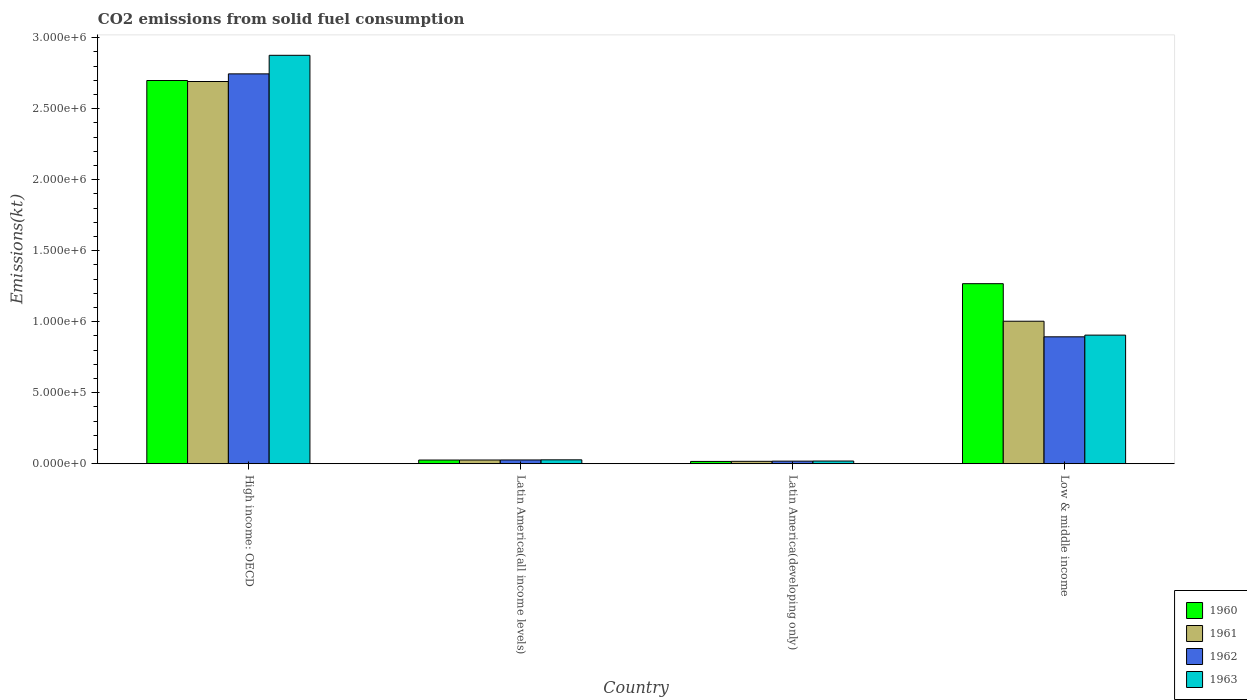How many groups of bars are there?
Keep it short and to the point. 4. Are the number of bars per tick equal to the number of legend labels?
Your answer should be compact. Yes. Are the number of bars on each tick of the X-axis equal?
Make the answer very short. Yes. What is the label of the 4th group of bars from the left?
Offer a terse response. Low & middle income. What is the amount of CO2 emitted in 1961 in Latin America(all income levels)?
Give a very brief answer. 2.63e+04. Across all countries, what is the maximum amount of CO2 emitted in 1962?
Your answer should be very brief. 2.75e+06. Across all countries, what is the minimum amount of CO2 emitted in 1962?
Your response must be concise. 1.83e+04. In which country was the amount of CO2 emitted in 1963 maximum?
Give a very brief answer. High income: OECD. In which country was the amount of CO2 emitted in 1960 minimum?
Give a very brief answer. Latin America(developing only). What is the total amount of CO2 emitted in 1962 in the graph?
Your answer should be very brief. 3.68e+06. What is the difference between the amount of CO2 emitted in 1963 in Latin America(all income levels) and that in Low & middle income?
Offer a terse response. -8.78e+05. What is the difference between the amount of CO2 emitted in 1961 in Latin America(all income levels) and the amount of CO2 emitted in 1962 in Low & middle income?
Give a very brief answer. -8.67e+05. What is the average amount of CO2 emitted in 1960 per country?
Provide a succinct answer. 1.00e+06. What is the difference between the amount of CO2 emitted of/in 1960 and amount of CO2 emitted of/in 1961 in Low & middle income?
Provide a succinct answer. 2.64e+05. What is the ratio of the amount of CO2 emitted in 1960 in Latin America(developing only) to that in Low & middle income?
Offer a very short reply. 0.01. Is the amount of CO2 emitted in 1963 in Latin America(developing only) less than that in Low & middle income?
Offer a very short reply. Yes. Is the difference between the amount of CO2 emitted in 1960 in High income: OECD and Latin America(all income levels) greater than the difference between the amount of CO2 emitted in 1961 in High income: OECD and Latin America(all income levels)?
Give a very brief answer. Yes. What is the difference between the highest and the second highest amount of CO2 emitted in 1962?
Offer a very short reply. 8.67e+05. What is the difference between the highest and the lowest amount of CO2 emitted in 1961?
Offer a very short reply. 2.67e+06. Is it the case that in every country, the sum of the amount of CO2 emitted in 1962 and amount of CO2 emitted in 1963 is greater than the sum of amount of CO2 emitted in 1961 and amount of CO2 emitted in 1960?
Provide a succinct answer. No. What does the 2nd bar from the left in Low & middle income represents?
Keep it short and to the point. 1961. Is it the case that in every country, the sum of the amount of CO2 emitted in 1962 and amount of CO2 emitted in 1961 is greater than the amount of CO2 emitted in 1960?
Offer a terse response. Yes. Are all the bars in the graph horizontal?
Provide a succinct answer. No. Are the values on the major ticks of Y-axis written in scientific E-notation?
Keep it short and to the point. Yes. Does the graph contain grids?
Make the answer very short. No. How many legend labels are there?
Keep it short and to the point. 4. What is the title of the graph?
Ensure brevity in your answer.  CO2 emissions from solid fuel consumption. Does "1995" appear as one of the legend labels in the graph?
Provide a succinct answer. No. What is the label or title of the Y-axis?
Provide a succinct answer. Emissions(kt). What is the Emissions(kt) in 1960 in High income: OECD?
Your answer should be very brief. 2.70e+06. What is the Emissions(kt) in 1961 in High income: OECD?
Provide a short and direct response. 2.69e+06. What is the Emissions(kt) of 1962 in High income: OECD?
Provide a succinct answer. 2.75e+06. What is the Emissions(kt) in 1963 in High income: OECD?
Your answer should be compact. 2.88e+06. What is the Emissions(kt) in 1960 in Latin America(all income levels)?
Your response must be concise. 2.60e+04. What is the Emissions(kt) of 1961 in Latin America(all income levels)?
Provide a short and direct response. 2.63e+04. What is the Emissions(kt) in 1962 in Latin America(all income levels)?
Your answer should be compact. 2.67e+04. What is the Emissions(kt) in 1963 in Latin America(all income levels)?
Ensure brevity in your answer.  2.75e+04. What is the Emissions(kt) in 1960 in Latin America(developing only)?
Ensure brevity in your answer.  1.62e+04. What is the Emissions(kt) of 1961 in Latin America(developing only)?
Make the answer very short. 1.70e+04. What is the Emissions(kt) of 1962 in Latin America(developing only)?
Provide a succinct answer. 1.83e+04. What is the Emissions(kt) of 1963 in Latin America(developing only)?
Keep it short and to the point. 1.90e+04. What is the Emissions(kt) in 1960 in Low & middle income?
Your answer should be very brief. 1.27e+06. What is the Emissions(kt) in 1961 in Low & middle income?
Offer a terse response. 1.00e+06. What is the Emissions(kt) of 1962 in Low & middle income?
Your answer should be compact. 8.94e+05. What is the Emissions(kt) of 1963 in Low & middle income?
Your response must be concise. 9.06e+05. Across all countries, what is the maximum Emissions(kt) of 1960?
Provide a short and direct response. 2.70e+06. Across all countries, what is the maximum Emissions(kt) of 1961?
Ensure brevity in your answer.  2.69e+06. Across all countries, what is the maximum Emissions(kt) of 1962?
Provide a short and direct response. 2.75e+06. Across all countries, what is the maximum Emissions(kt) of 1963?
Your answer should be compact. 2.88e+06. Across all countries, what is the minimum Emissions(kt) in 1960?
Make the answer very short. 1.62e+04. Across all countries, what is the minimum Emissions(kt) in 1961?
Provide a short and direct response. 1.70e+04. Across all countries, what is the minimum Emissions(kt) in 1962?
Your response must be concise. 1.83e+04. Across all countries, what is the minimum Emissions(kt) of 1963?
Provide a succinct answer. 1.90e+04. What is the total Emissions(kt) of 1960 in the graph?
Keep it short and to the point. 4.01e+06. What is the total Emissions(kt) in 1961 in the graph?
Keep it short and to the point. 3.74e+06. What is the total Emissions(kt) in 1962 in the graph?
Provide a succinct answer. 3.68e+06. What is the total Emissions(kt) in 1963 in the graph?
Offer a very short reply. 3.83e+06. What is the difference between the Emissions(kt) in 1960 in High income: OECD and that in Latin America(all income levels)?
Provide a short and direct response. 2.67e+06. What is the difference between the Emissions(kt) in 1961 in High income: OECD and that in Latin America(all income levels)?
Offer a very short reply. 2.67e+06. What is the difference between the Emissions(kt) of 1962 in High income: OECD and that in Latin America(all income levels)?
Offer a terse response. 2.72e+06. What is the difference between the Emissions(kt) of 1963 in High income: OECD and that in Latin America(all income levels)?
Your answer should be very brief. 2.85e+06. What is the difference between the Emissions(kt) in 1960 in High income: OECD and that in Latin America(developing only)?
Make the answer very short. 2.68e+06. What is the difference between the Emissions(kt) of 1961 in High income: OECD and that in Latin America(developing only)?
Give a very brief answer. 2.67e+06. What is the difference between the Emissions(kt) of 1962 in High income: OECD and that in Latin America(developing only)?
Ensure brevity in your answer.  2.73e+06. What is the difference between the Emissions(kt) in 1963 in High income: OECD and that in Latin America(developing only)?
Provide a succinct answer. 2.86e+06. What is the difference between the Emissions(kt) of 1960 in High income: OECD and that in Low & middle income?
Make the answer very short. 1.43e+06. What is the difference between the Emissions(kt) of 1961 in High income: OECD and that in Low & middle income?
Your answer should be compact. 1.69e+06. What is the difference between the Emissions(kt) of 1962 in High income: OECD and that in Low & middle income?
Your answer should be compact. 1.85e+06. What is the difference between the Emissions(kt) in 1963 in High income: OECD and that in Low & middle income?
Your response must be concise. 1.97e+06. What is the difference between the Emissions(kt) of 1960 in Latin America(all income levels) and that in Latin America(developing only)?
Ensure brevity in your answer.  9759.8. What is the difference between the Emissions(kt) in 1961 in Latin America(all income levels) and that in Latin America(developing only)?
Offer a very short reply. 9282.45. What is the difference between the Emissions(kt) in 1962 in Latin America(all income levels) and that in Latin America(developing only)?
Your answer should be compact. 8301.83. What is the difference between the Emissions(kt) of 1963 in Latin America(all income levels) and that in Latin America(developing only)?
Make the answer very short. 8542.91. What is the difference between the Emissions(kt) of 1960 in Latin America(all income levels) and that in Low & middle income?
Provide a short and direct response. -1.24e+06. What is the difference between the Emissions(kt) in 1961 in Latin America(all income levels) and that in Low & middle income?
Keep it short and to the point. -9.77e+05. What is the difference between the Emissions(kt) of 1962 in Latin America(all income levels) and that in Low & middle income?
Ensure brevity in your answer.  -8.67e+05. What is the difference between the Emissions(kt) of 1963 in Latin America(all income levels) and that in Low & middle income?
Provide a succinct answer. -8.78e+05. What is the difference between the Emissions(kt) of 1960 in Latin America(developing only) and that in Low & middle income?
Make the answer very short. -1.25e+06. What is the difference between the Emissions(kt) in 1961 in Latin America(developing only) and that in Low & middle income?
Offer a very short reply. -9.86e+05. What is the difference between the Emissions(kt) in 1962 in Latin America(developing only) and that in Low & middle income?
Provide a short and direct response. -8.75e+05. What is the difference between the Emissions(kt) of 1963 in Latin America(developing only) and that in Low & middle income?
Keep it short and to the point. -8.87e+05. What is the difference between the Emissions(kt) in 1960 in High income: OECD and the Emissions(kt) in 1961 in Latin America(all income levels)?
Ensure brevity in your answer.  2.67e+06. What is the difference between the Emissions(kt) of 1960 in High income: OECD and the Emissions(kt) of 1962 in Latin America(all income levels)?
Keep it short and to the point. 2.67e+06. What is the difference between the Emissions(kt) of 1960 in High income: OECD and the Emissions(kt) of 1963 in Latin America(all income levels)?
Provide a succinct answer. 2.67e+06. What is the difference between the Emissions(kt) in 1961 in High income: OECD and the Emissions(kt) in 1962 in Latin America(all income levels)?
Your answer should be very brief. 2.66e+06. What is the difference between the Emissions(kt) in 1961 in High income: OECD and the Emissions(kt) in 1963 in Latin America(all income levels)?
Offer a very short reply. 2.66e+06. What is the difference between the Emissions(kt) of 1962 in High income: OECD and the Emissions(kt) of 1963 in Latin America(all income levels)?
Give a very brief answer. 2.72e+06. What is the difference between the Emissions(kt) of 1960 in High income: OECD and the Emissions(kt) of 1961 in Latin America(developing only)?
Give a very brief answer. 2.68e+06. What is the difference between the Emissions(kt) in 1960 in High income: OECD and the Emissions(kt) in 1962 in Latin America(developing only)?
Ensure brevity in your answer.  2.68e+06. What is the difference between the Emissions(kt) in 1960 in High income: OECD and the Emissions(kt) in 1963 in Latin America(developing only)?
Offer a terse response. 2.68e+06. What is the difference between the Emissions(kt) in 1961 in High income: OECD and the Emissions(kt) in 1962 in Latin America(developing only)?
Offer a terse response. 2.67e+06. What is the difference between the Emissions(kt) of 1961 in High income: OECD and the Emissions(kt) of 1963 in Latin America(developing only)?
Give a very brief answer. 2.67e+06. What is the difference between the Emissions(kt) in 1962 in High income: OECD and the Emissions(kt) in 1963 in Latin America(developing only)?
Offer a very short reply. 2.73e+06. What is the difference between the Emissions(kt) of 1960 in High income: OECD and the Emissions(kt) of 1961 in Low & middle income?
Keep it short and to the point. 1.69e+06. What is the difference between the Emissions(kt) of 1960 in High income: OECD and the Emissions(kt) of 1962 in Low & middle income?
Ensure brevity in your answer.  1.80e+06. What is the difference between the Emissions(kt) in 1960 in High income: OECD and the Emissions(kt) in 1963 in Low & middle income?
Your answer should be very brief. 1.79e+06. What is the difference between the Emissions(kt) in 1961 in High income: OECD and the Emissions(kt) in 1962 in Low & middle income?
Your response must be concise. 1.80e+06. What is the difference between the Emissions(kt) of 1961 in High income: OECD and the Emissions(kt) of 1963 in Low & middle income?
Offer a very short reply. 1.79e+06. What is the difference between the Emissions(kt) in 1962 in High income: OECD and the Emissions(kt) in 1963 in Low & middle income?
Ensure brevity in your answer.  1.84e+06. What is the difference between the Emissions(kt) of 1960 in Latin America(all income levels) and the Emissions(kt) of 1961 in Latin America(developing only)?
Your answer should be compact. 9031.46. What is the difference between the Emissions(kt) of 1960 in Latin America(all income levels) and the Emissions(kt) of 1962 in Latin America(developing only)?
Provide a short and direct response. 7658.68. What is the difference between the Emissions(kt) of 1960 in Latin America(all income levels) and the Emissions(kt) of 1963 in Latin America(developing only)?
Ensure brevity in your answer.  7040.93. What is the difference between the Emissions(kt) in 1961 in Latin America(all income levels) and the Emissions(kt) in 1962 in Latin America(developing only)?
Make the answer very short. 7909.66. What is the difference between the Emissions(kt) of 1961 in Latin America(all income levels) and the Emissions(kt) of 1963 in Latin America(developing only)?
Provide a succinct answer. 7291.91. What is the difference between the Emissions(kt) of 1962 in Latin America(all income levels) and the Emissions(kt) of 1963 in Latin America(developing only)?
Your answer should be very brief. 7684.07. What is the difference between the Emissions(kt) in 1960 in Latin America(all income levels) and the Emissions(kt) in 1961 in Low & middle income?
Provide a succinct answer. -9.77e+05. What is the difference between the Emissions(kt) in 1960 in Latin America(all income levels) and the Emissions(kt) in 1962 in Low & middle income?
Keep it short and to the point. -8.68e+05. What is the difference between the Emissions(kt) in 1960 in Latin America(all income levels) and the Emissions(kt) in 1963 in Low & middle income?
Your answer should be very brief. -8.80e+05. What is the difference between the Emissions(kt) in 1961 in Latin America(all income levels) and the Emissions(kt) in 1962 in Low & middle income?
Your response must be concise. -8.67e+05. What is the difference between the Emissions(kt) of 1961 in Latin America(all income levels) and the Emissions(kt) of 1963 in Low & middle income?
Offer a very short reply. -8.79e+05. What is the difference between the Emissions(kt) in 1962 in Latin America(all income levels) and the Emissions(kt) in 1963 in Low & middle income?
Your response must be concise. -8.79e+05. What is the difference between the Emissions(kt) of 1960 in Latin America(developing only) and the Emissions(kt) of 1961 in Low & middle income?
Provide a succinct answer. -9.87e+05. What is the difference between the Emissions(kt) in 1960 in Latin America(developing only) and the Emissions(kt) in 1962 in Low & middle income?
Offer a terse response. -8.77e+05. What is the difference between the Emissions(kt) of 1960 in Latin America(developing only) and the Emissions(kt) of 1963 in Low & middle income?
Your response must be concise. -8.89e+05. What is the difference between the Emissions(kt) in 1961 in Latin America(developing only) and the Emissions(kt) in 1962 in Low & middle income?
Your answer should be compact. -8.77e+05. What is the difference between the Emissions(kt) of 1961 in Latin America(developing only) and the Emissions(kt) of 1963 in Low & middle income?
Provide a succinct answer. -8.89e+05. What is the difference between the Emissions(kt) of 1962 in Latin America(developing only) and the Emissions(kt) of 1963 in Low & middle income?
Your response must be concise. -8.87e+05. What is the average Emissions(kt) in 1960 per country?
Ensure brevity in your answer.  1.00e+06. What is the average Emissions(kt) of 1961 per country?
Offer a very short reply. 9.34e+05. What is the average Emissions(kt) of 1962 per country?
Provide a succinct answer. 9.21e+05. What is the average Emissions(kt) of 1963 per country?
Offer a very short reply. 9.57e+05. What is the difference between the Emissions(kt) of 1960 and Emissions(kt) of 1961 in High income: OECD?
Your answer should be compact. 7090.26. What is the difference between the Emissions(kt) in 1960 and Emissions(kt) in 1962 in High income: OECD?
Keep it short and to the point. -4.67e+04. What is the difference between the Emissions(kt) of 1960 and Emissions(kt) of 1963 in High income: OECD?
Offer a very short reply. -1.77e+05. What is the difference between the Emissions(kt) of 1961 and Emissions(kt) of 1962 in High income: OECD?
Offer a very short reply. -5.38e+04. What is the difference between the Emissions(kt) of 1961 and Emissions(kt) of 1963 in High income: OECD?
Offer a very short reply. -1.85e+05. What is the difference between the Emissions(kt) in 1962 and Emissions(kt) in 1963 in High income: OECD?
Offer a very short reply. -1.31e+05. What is the difference between the Emissions(kt) of 1960 and Emissions(kt) of 1961 in Latin America(all income levels)?
Provide a succinct answer. -250.98. What is the difference between the Emissions(kt) of 1960 and Emissions(kt) of 1962 in Latin America(all income levels)?
Give a very brief answer. -643.15. What is the difference between the Emissions(kt) in 1960 and Emissions(kt) in 1963 in Latin America(all income levels)?
Your answer should be compact. -1501.98. What is the difference between the Emissions(kt) in 1961 and Emissions(kt) in 1962 in Latin America(all income levels)?
Your answer should be very brief. -392.16. What is the difference between the Emissions(kt) of 1961 and Emissions(kt) of 1963 in Latin America(all income levels)?
Offer a terse response. -1251. What is the difference between the Emissions(kt) in 1962 and Emissions(kt) in 1963 in Latin America(all income levels)?
Offer a terse response. -858.84. What is the difference between the Emissions(kt) of 1960 and Emissions(kt) of 1961 in Latin America(developing only)?
Make the answer very short. -728.34. What is the difference between the Emissions(kt) of 1960 and Emissions(kt) of 1962 in Latin America(developing only)?
Make the answer very short. -2101.12. What is the difference between the Emissions(kt) of 1960 and Emissions(kt) of 1963 in Latin America(developing only)?
Your response must be concise. -2718.88. What is the difference between the Emissions(kt) in 1961 and Emissions(kt) in 1962 in Latin America(developing only)?
Your answer should be very brief. -1372.79. What is the difference between the Emissions(kt) of 1961 and Emissions(kt) of 1963 in Latin America(developing only)?
Your answer should be very brief. -1990.54. What is the difference between the Emissions(kt) of 1962 and Emissions(kt) of 1963 in Latin America(developing only)?
Your answer should be very brief. -617.75. What is the difference between the Emissions(kt) of 1960 and Emissions(kt) of 1961 in Low & middle income?
Offer a very short reply. 2.64e+05. What is the difference between the Emissions(kt) of 1960 and Emissions(kt) of 1962 in Low & middle income?
Offer a very short reply. 3.74e+05. What is the difference between the Emissions(kt) of 1960 and Emissions(kt) of 1963 in Low & middle income?
Keep it short and to the point. 3.62e+05. What is the difference between the Emissions(kt) of 1961 and Emissions(kt) of 1962 in Low & middle income?
Your answer should be very brief. 1.10e+05. What is the difference between the Emissions(kt) in 1961 and Emissions(kt) in 1963 in Low & middle income?
Offer a very short reply. 9.78e+04. What is the difference between the Emissions(kt) in 1962 and Emissions(kt) in 1963 in Low & middle income?
Give a very brief answer. -1.20e+04. What is the ratio of the Emissions(kt) of 1960 in High income: OECD to that in Latin America(all income levels)?
Your response must be concise. 103.75. What is the ratio of the Emissions(kt) of 1961 in High income: OECD to that in Latin America(all income levels)?
Ensure brevity in your answer.  102.49. What is the ratio of the Emissions(kt) of 1962 in High income: OECD to that in Latin America(all income levels)?
Keep it short and to the point. 103. What is the ratio of the Emissions(kt) in 1963 in High income: OECD to that in Latin America(all income levels)?
Keep it short and to the point. 104.54. What is the ratio of the Emissions(kt) in 1960 in High income: OECD to that in Latin America(developing only)?
Offer a very short reply. 166.07. What is the ratio of the Emissions(kt) in 1961 in High income: OECD to that in Latin America(developing only)?
Keep it short and to the point. 158.53. What is the ratio of the Emissions(kt) in 1962 in High income: OECD to that in Latin America(developing only)?
Provide a short and direct response. 149.6. What is the ratio of the Emissions(kt) of 1963 in High income: OECD to that in Latin America(developing only)?
Your response must be concise. 151.62. What is the ratio of the Emissions(kt) of 1960 in High income: OECD to that in Low & middle income?
Your response must be concise. 2.13. What is the ratio of the Emissions(kt) in 1961 in High income: OECD to that in Low & middle income?
Your answer should be compact. 2.68. What is the ratio of the Emissions(kt) in 1962 in High income: OECD to that in Low & middle income?
Provide a short and direct response. 3.07. What is the ratio of the Emissions(kt) of 1963 in High income: OECD to that in Low & middle income?
Ensure brevity in your answer.  3.18. What is the ratio of the Emissions(kt) of 1960 in Latin America(all income levels) to that in Latin America(developing only)?
Your answer should be very brief. 1.6. What is the ratio of the Emissions(kt) of 1961 in Latin America(all income levels) to that in Latin America(developing only)?
Your answer should be compact. 1.55. What is the ratio of the Emissions(kt) of 1962 in Latin America(all income levels) to that in Latin America(developing only)?
Ensure brevity in your answer.  1.45. What is the ratio of the Emissions(kt) in 1963 in Latin America(all income levels) to that in Latin America(developing only)?
Provide a succinct answer. 1.45. What is the ratio of the Emissions(kt) in 1960 in Latin America(all income levels) to that in Low & middle income?
Give a very brief answer. 0.02. What is the ratio of the Emissions(kt) of 1961 in Latin America(all income levels) to that in Low & middle income?
Make the answer very short. 0.03. What is the ratio of the Emissions(kt) of 1962 in Latin America(all income levels) to that in Low & middle income?
Provide a succinct answer. 0.03. What is the ratio of the Emissions(kt) of 1963 in Latin America(all income levels) to that in Low & middle income?
Make the answer very short. 0.03. What is the ratio of the Emissions(kt) of 1960 in Latin America(developing only) to that in Low & middle income?
Offer a very short reply. 0.01. What is the ratio of the Emissions(kt) of 1961 in Latin America(developing only) to that in Low & middle income?
Keep it short and to the point. 0.02. What is the ratio of the Emissions(kt) of 1962 in Latin America(developing only) to that in Low & middle income?
Give a very brief answer. 0.02. What is the ratio of the Emissions(kt) in 1963 in Latin America(developing only) to that in Low & middle income?
Your response must be concise. 0.02. What is the difference between the highest and the second highest Emissions(kt) of 1960?
Provide a succinct answer. 1.43e+06. What is the difference between the highest and the second highest Emissions(kt) of 1961?
Your answer should be very brief. 1.69e+06. What is the difference between the highest and the second highest Emissions(kt) of 1962?
Your response must be concise. 1.85e+06. What is the difference between the highest and the second highest Emissions(kt) of 1963?
Your answer should be very brief. 1.97e+06. What is the difference between the highest and the lowest Emissions(kt) in 1960?
Your answer should be very brief. 2.68e+06. What is the difference between the highest and the lowest Emissions(kt) of 1961?
Your answer should be compact. 2.67e+06. What is the difference between the highest and the lowest Emissions(kt) in 1962?
Ensure brevity in your answer.  2.73e+06. What is the difference between the highest and the lowest Emissions(kt) of 1963?
Offer a terse response. 2.86e+06. 